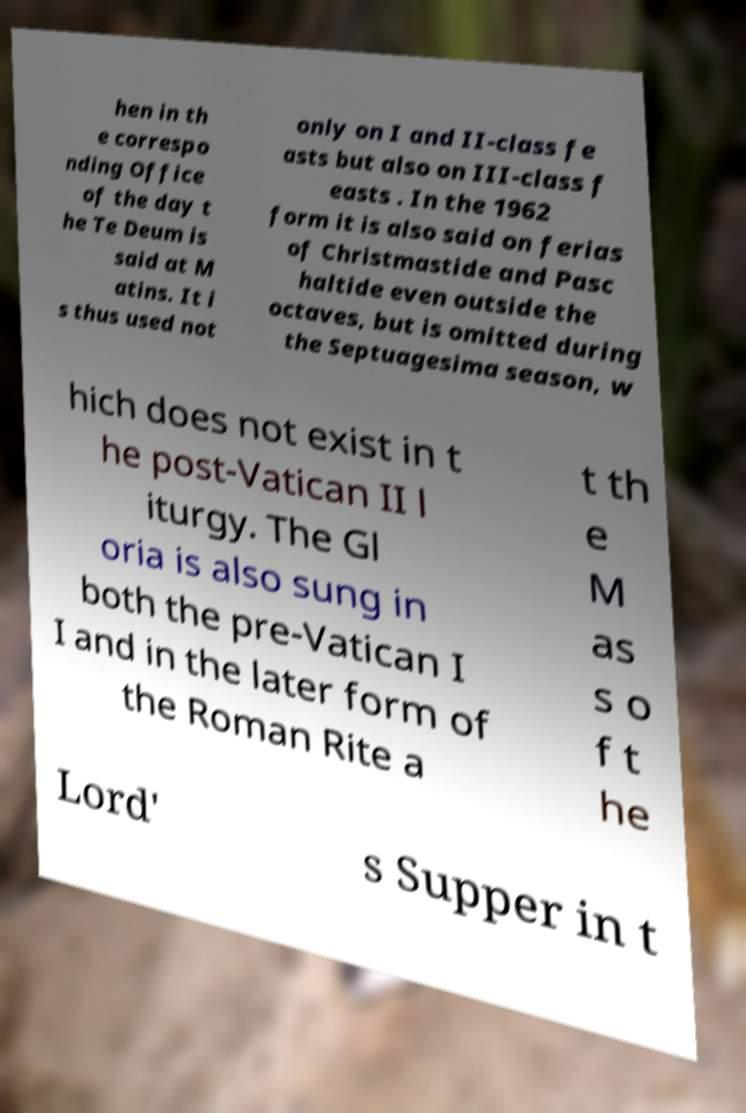Please read and relay the text visible in this image. What does it say? hen in th e correspo nding Office of the day t he Te Deum is said at M atins. It i s thus used not only on I and II-class fe asts but also on III-class f easts . In the 1962 form it is also said on ferias of Christmastide and Pasc haltide even outside the octaves, but is omitted during the Septuagesima season, w hich does not exist in t he post-Vatican II l iturgy. The Gl oria is also sung in both the pre-Vatican I I and in the later form of the Roman Rite a t th e M as s o f t he Lord' s Supper in t 